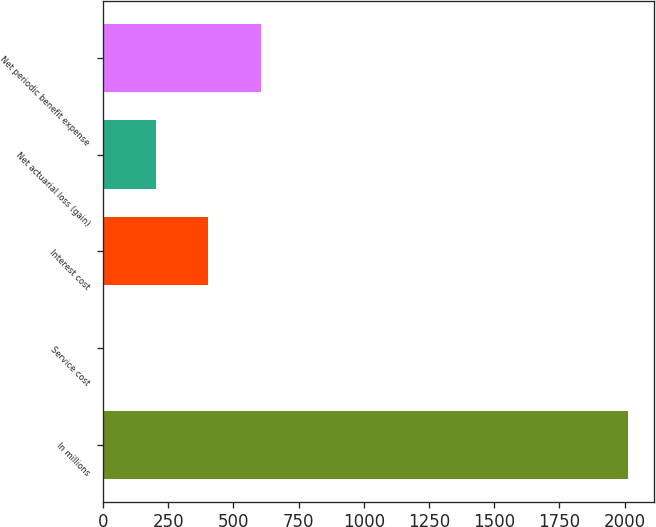Convert chart to OTSL. <chart><loc_0><loc_0><loc_500><loc_500><bar_chart><fcel>In millions<fcel>Service cost<fcel>Interest cost<fcel>Net actuarial loss (gain)<fcel>Net periodic benefit expense<nl><fcel>2014<fcel>0.2<fcel>402.96<fcel>201.58<fcel>604.34<nl></chart> 